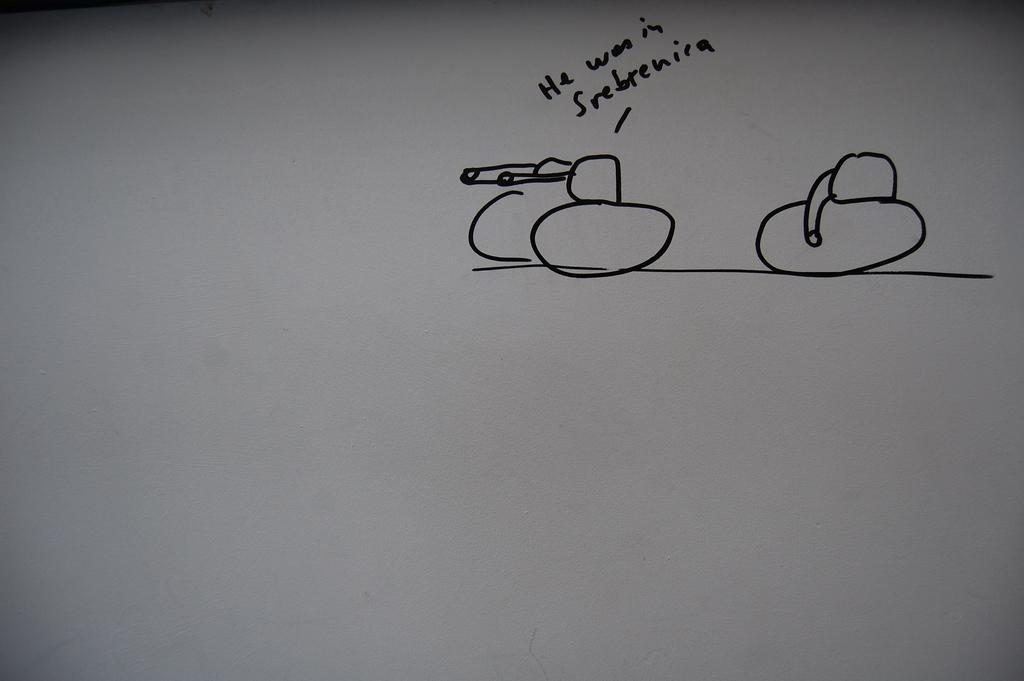Could you give a brief overview of what you see in this image? Here in this picture we can see a paper present, on which we can see some drawing and a text written on it over there. 